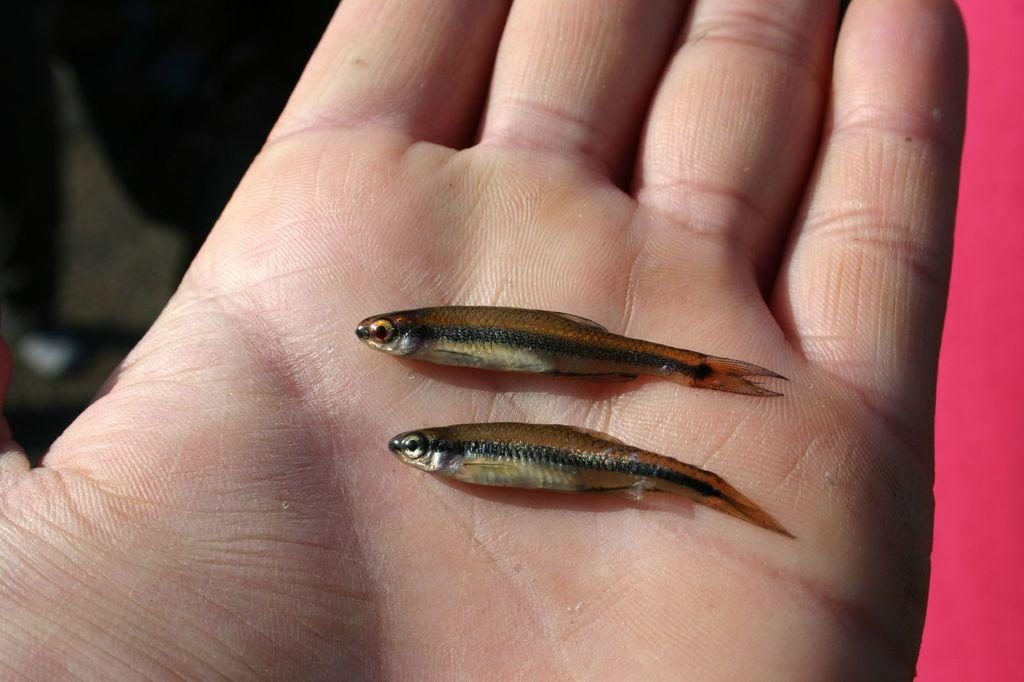What animals are present in the image? There are two small fishes in the image. Where are the fishes located? The fishes are in a person's hand. What type of burn is the monkey experiencing in the image? There is no monkey present in the image, and therefore no burn can be observed. 